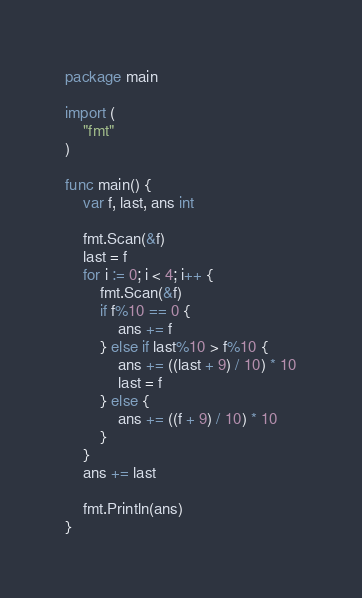<code> <loc_0><loc_0><loc_500><loc_500><_Go_>package main

import (
	"fmt"
)

func main() {
	var f, last, ans int

	fmt.Scan(&f)
	last = f
	for i := 0; i < 4; i++ {
		fmt.Scan(&f)
		if f%10 == 0 {
			ans += f
		} else if last%10 > f%10 {
			ans += ((last + 9) / 10) * 10
			last = f
		} else {
			ans += ((f + 9) / 10) * 10
		}
	}
	ans += last

	fmt.Println(ans)
}
</code> 